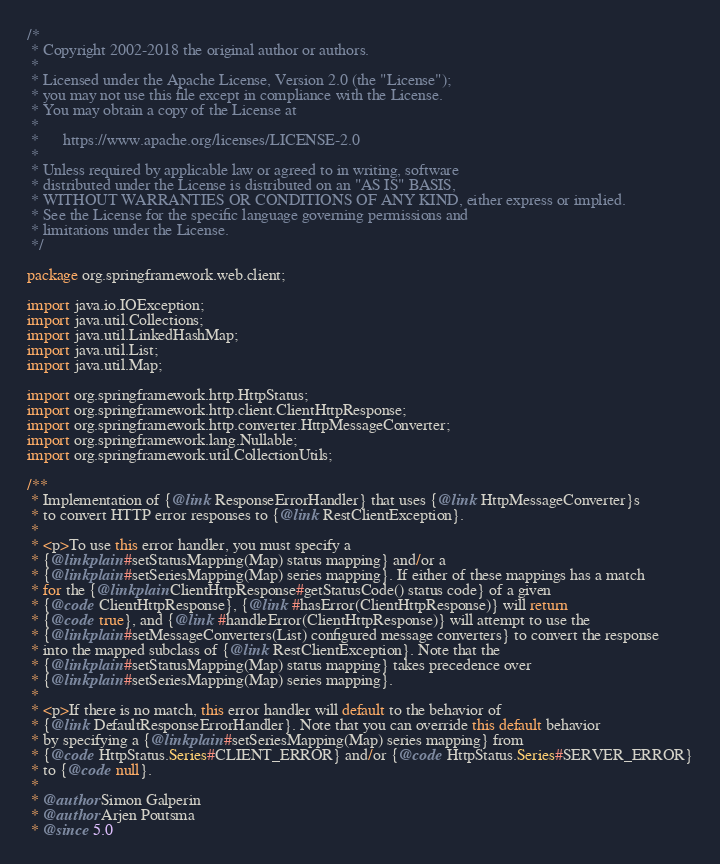Convert code to text. <code><loc_0><loc_0><loc_500><loc_500><_Java_>/*
 * Copyright 2002-2018 the original author or authors.
 *
 * Licensed under the Apache License, Version 2.0 (the "License");
 * you may not use this file except in compliance with the License.
 * You may obtain a copy of the License at
 *
 *      https://www.apache.org/licenses/LICENSE-2.0
 *
 * Unless required by applicable law or agreed to in writing, software
 * distributed under the License is distributed on an "AS IS" BASIS,
 * WITHOUT WARRANTIES OR CONDITIONS OF ANY KIND, either express or implied.
 * See the License for the specific language governing permissions and
 * limitations under the License.
 */

package org.springframework.web.client;

import java.io.IOException;
import java.util.Collections;
import java.util.LinkedHashMap;
import java.util.List;
import java.util.Map;

import org.springframework.http.HttpStatus;
import org.springframework.http.client.ClientHttpResponse;
import org.springframework.http.converter.HttpMessageConverter;
import org.springframework.lang.Nullable;
import org.springframework.util.CollectionUtils;

/**
 * Implementation of {@link ResponseErrorHandler} that uses {@link HttpMessageConverter}s
 * to convert HTTP error responses to {@link RestClientException}.
 *
 * <p>To use this error handler, you must specify a
 * {@linkplain #setStatusMapping(Map) status mapping} and/or a
 * {@linkplain #setSeriesMapping(Map) series mapping}. If either of these mappings has a match
 * for the {@linkplain ClientHttpResponse#getStatusCode() status code} of a given
 * {@code ClientHttpResponse}, {@link #hasError(ClientHttpResponse)} will return
 * {@code true}, and {@link #handleError(ClientHttpResponse)} will attempt to use the
 * {@linkplain #setMessageConverters(List) configured message converters} to convert the response
 * into the mapped subclass of {@link RestClientException}. Note that the
 * {@linkplain #setStatusMapping(Map) status mapping} takes precedence over
 * {@linkplain #setSeriesMapping(Map) series mapping}.
 *
 * <p>If there is no match, this error handler will default to the behavior of
 * {@link DefaultResponseErrorHandler}. Note that you can override this default behavior
 * by specifying a {@linkplain #setSeriesMapping(Map) series mapping} from
 * {@code HttpStatus.Series#CLIENT_ERROR} and/or {@code HttpStatus.Series#SERVER_ERROR}
 * to {@code null}.
 *
 * @author Simon Galperin
 * @author Arjen Poutsma
 * @since 5.0</code> 